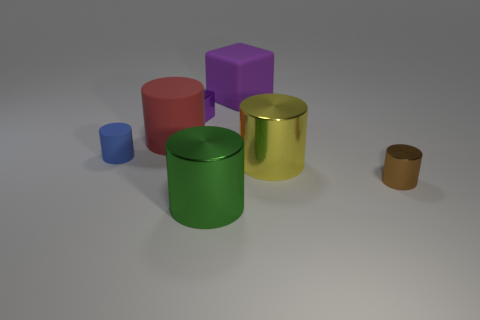Subtract all cyan cylinders. Subtract all yellow cubes. How many cylinders are left? 5 Add 3 blue matte objects. How many objects exist? 10 Subtract all cylinders. How many objects are left? 2 Add 2 tiny brown metal cylinders. How many tiny brown metal cylinders exist? 3 Subtract 1 red cylinders. How many objects are left? 6 Subtract all tiny brown shiny cylinders. Subtract all small green shiny cylinders. How many objects are left? 6 Add 1 rubber objects. How many rubber objects are left? 4 